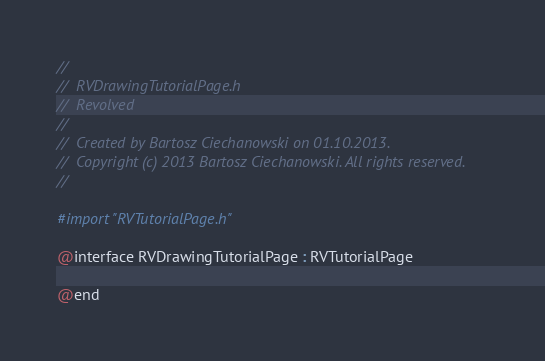<code> <loc_0><loc_0><loc_500><loc_500><_C_>//
//  RVDrawingTutorialPage.h
//  Revolved
//
//  Created by Bartosz Ciechanowski on 01.10.2013.
//  Copyright (c) 2013 Bartosz Ciechanowski. All rights reserved.
//

#import "RVTutorialPage.h"

@interface RVDrawingTutorialPage : RVTutorialPage

@end
</code> 